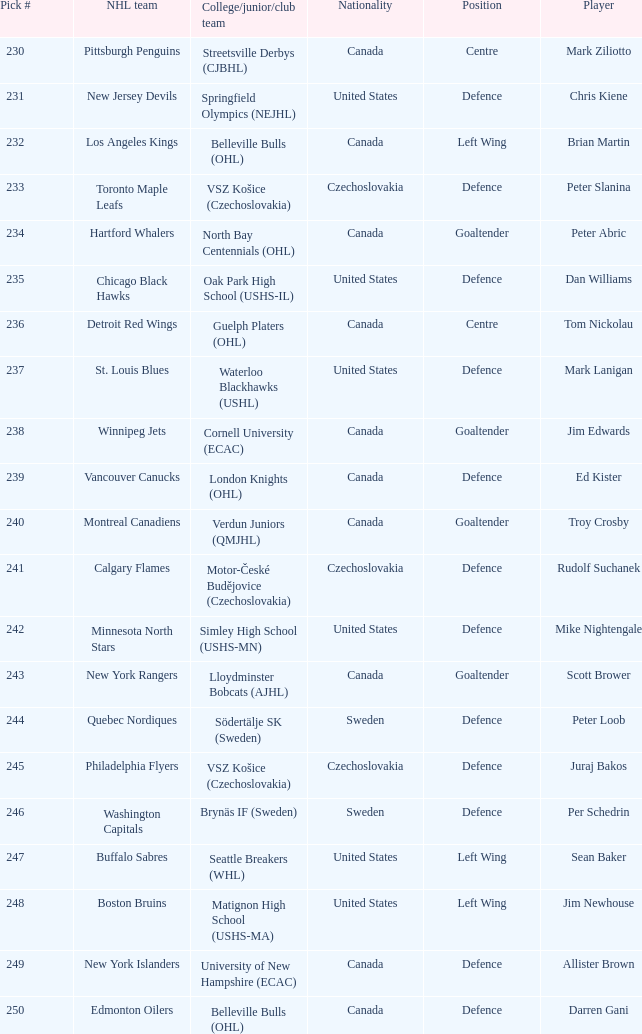Which draft number did the new jersey devils get? 231.0. 